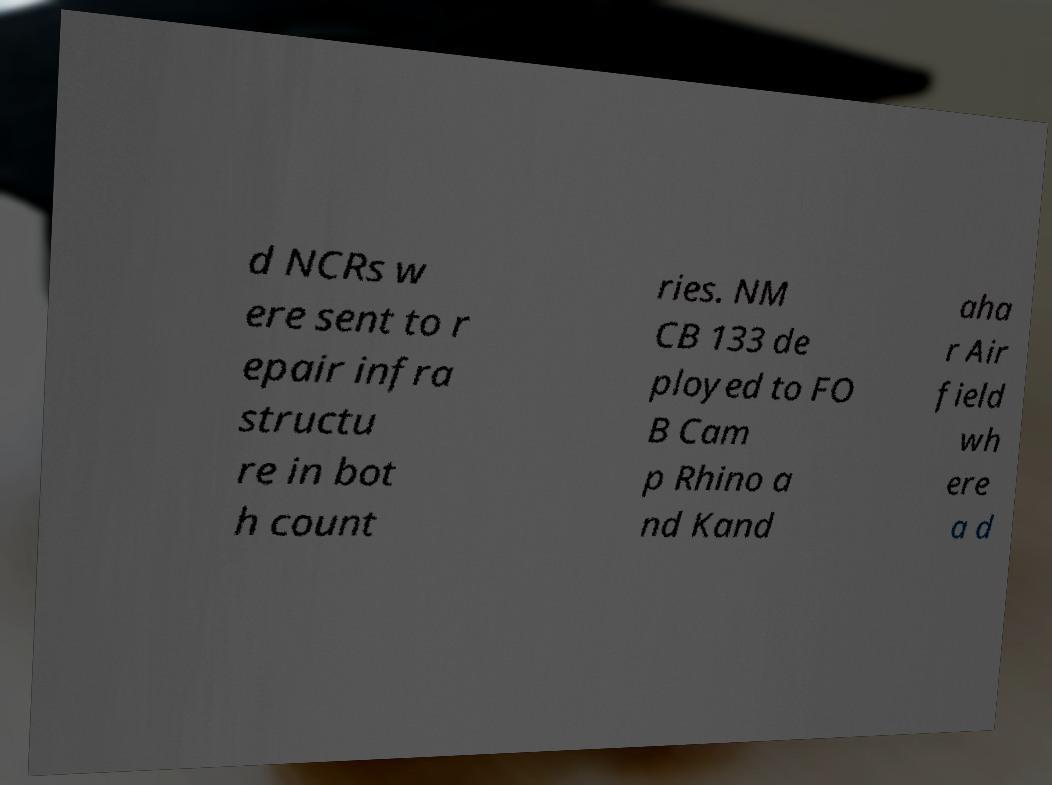I need the written content from this picture converted into text. Can you do that? d NCRs w ere sent to r epair infra structu re in bot h count ries. NM CB 133 de ployed to FO B Cam p Rhino a nd Kand aha r Air field wh ere a d 